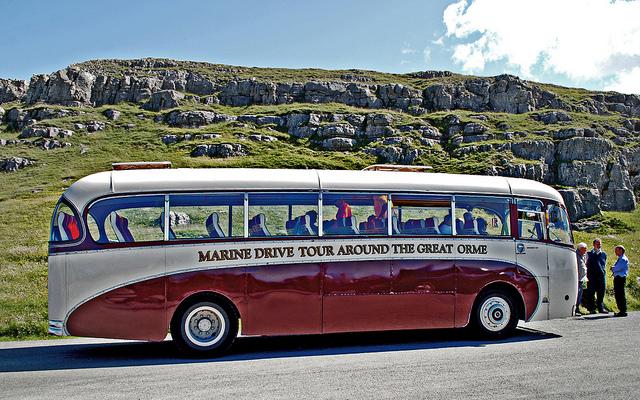What two colors are the bus?
Answer briefly. Red and white. What colors are inside the bus?
Answer briefly. Blue. What name is on the bus?
Write a very short answer. Marine drive tour around great orme. Are the tires the same?
Keep it brief. Yes. 